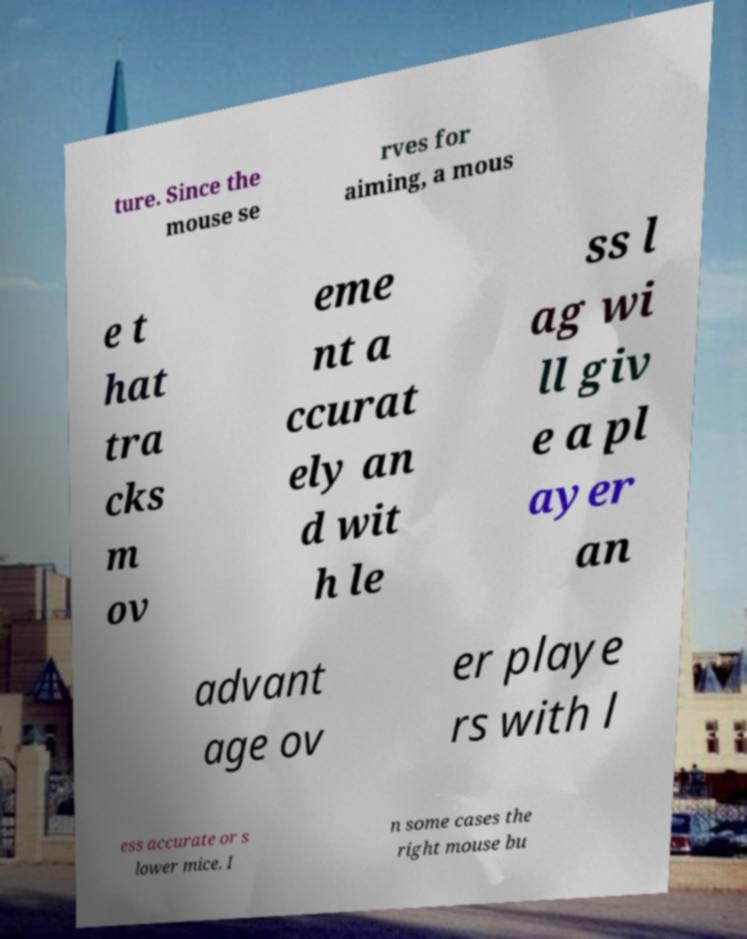There's text embedded in this image that I need extracted. Can you transcribe it verbatim? ture. Since the mouse se rves for aiming, a mous e t hat tra cks m ov eme nt a ccurat ely an d wit h le ss l ag wi ll giv e a pl ayer an advant age ov er playe rs with l ess accurate or s lower mice. I n some cases the right mouse bu 